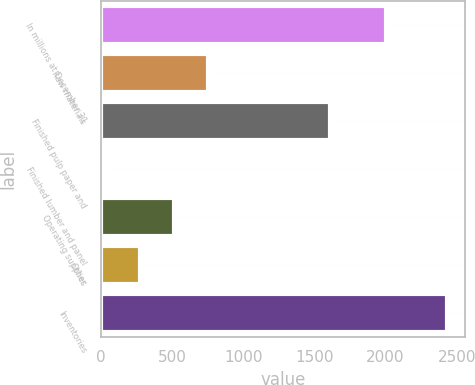Convert chart to OTSL. <chart><loc_0><loc_0><loc_500><loc_500><bar_chart><fcel>In millions at December 31<fcel>Raw materials<fcel>Finished pulp paper and<fcel>Finished lumber and panel<fcel>Operating supplies<fcel>Other<fcel>Inventories<nl><fcel>2005<fcel>753.3<fcel>1611<fcel>33<fcel>513.2<fcel>273.1<fcel>2434<nl></chart> 